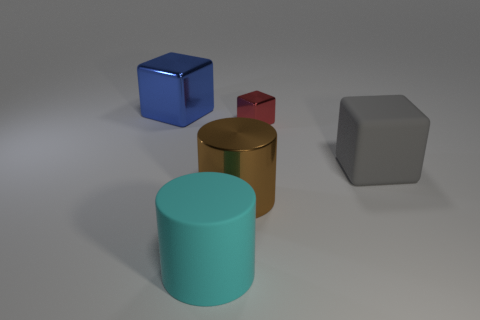Add 4 green metal blocks. How many objects exist? 9 Subtract all large blocks. How many blocks are left? 1 Subtract all small blue shiny cylinders. Subtract all tiny shiny blocks. How many objects are left? 4 Add 3 big blue metal objects. How many big blue metal objects are left? 4 Add 1 big cyan objects. How many big cyan objects exist? 2 Subtract all brown cylinders. How many cylinders are left? 1 Subtract 0 cyan blocks. How many objects are left? 5 Subtract all cylinders. How many objects are left? 3 Subtract 1 blocks. How many blocks are left? 2 Subtract all cyan cubes. Subtract all red cylinders. How many cubes are left? 3 